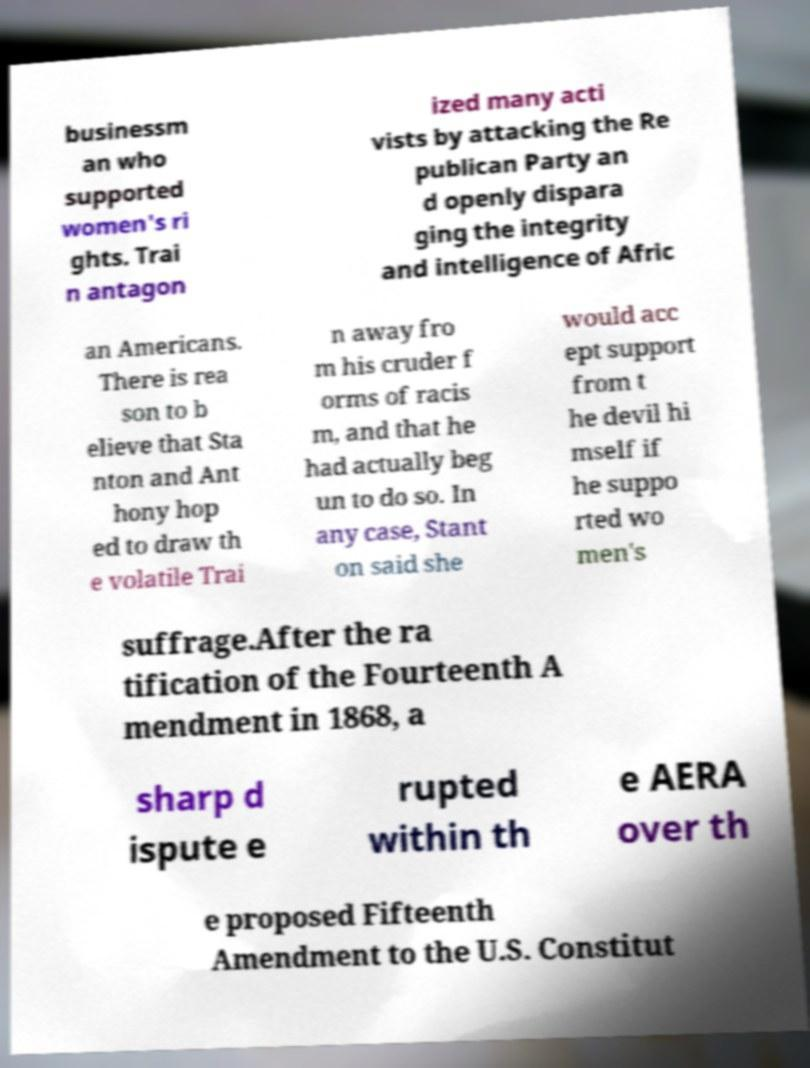Can you accurately transcribe the text from the provided image for me? businessm an who supported women's ri ghts. Trai n antagon ized many acti vists by attacking the Re publican Party an d openly dispara ging the integrity and intelligence of Afric an Americans. There is rea son to b elieve that Sta nton and Ant hony hop ed to draw th e volatile Trai n away fro m his cruder f orms of racis m, and that he had actually beg un to do so. In any case, Stant on said she would acc ept support from t he devil hi mself if he suppo rted wo men's suffrage.After the ra tification of the Fourteenth A mendment in 1868, a sharp d ispute e rupted within th e AERA over th e proposed Fifteenth Amendment to the U.S. Constitut 